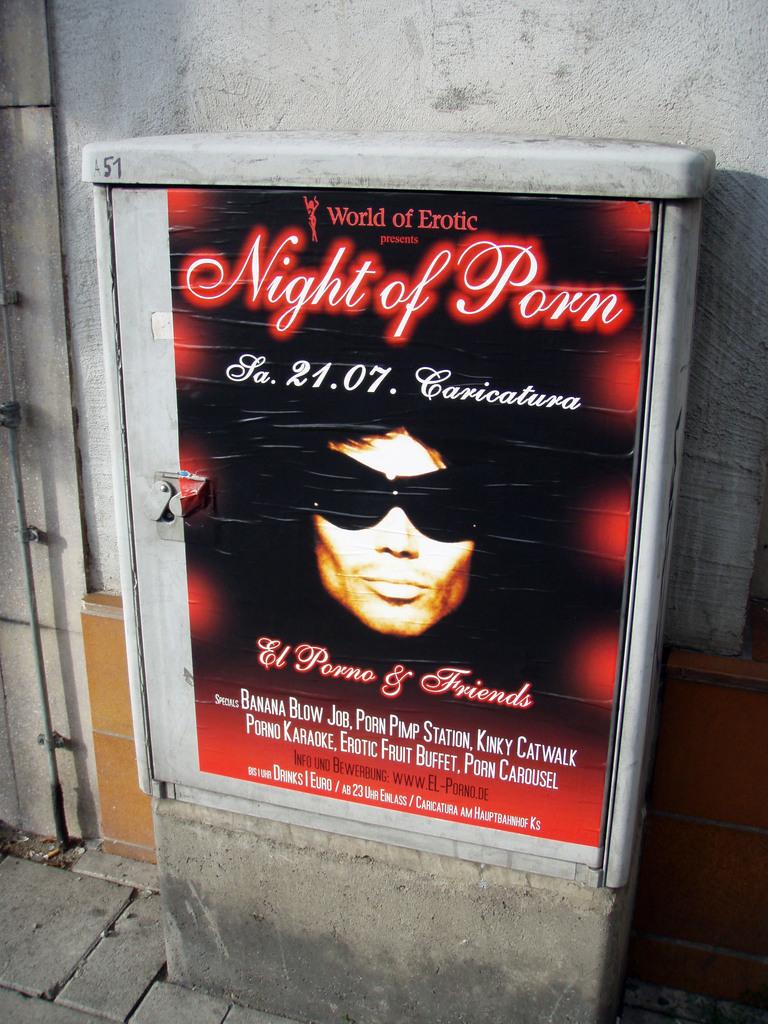When is the event?
Your answer should be compact. Night of porn. Who is presenting the advertised event?
Ensure brevity in your answer.  World of erotic. 